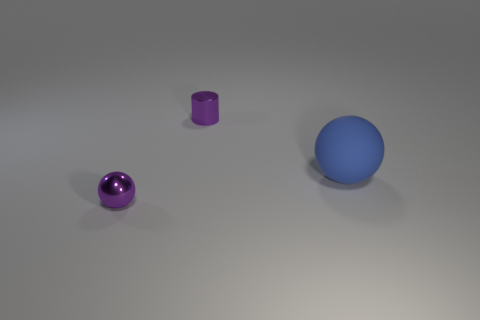Are the purple ball left of the purple cylinder and the ball that is behind the metallic sphere made of the same material?
Your response must be concise. No. There is a shiny thing that is behind the tiny purple thing in front of the small metallic cylinder; what number of small purple objects are left of it?
Offer a terse response. 1. There is a metallic object behind the large blue thing; does it have the same color as the ball that is left of the blue sphere?
Keep it short and to the point. Yes. Is there any other thing that is the same color as the tiny cylinder?
Your response must be concise. Yes. There is a small metallic thing in front of the shiny thing behind the big blue sphere; what is its color?
Give a very brief answer. Purple. Are there any large red things?
Your response must be concise. No. There is a object that is both behind the purple ball and in front of the tiny purple metallic cylinder; what is its color?
Offer a very short reply. Blue. There is a metal thing that is to the right of the metal sphere; is it the same size as the ball behind the tiny metallic ball?
Your answer should be very brief. No. What number of other objects are there of the same size as the metallic cylinder?
Your answer should be compact. 1. There is a metal object that is behind the big matte object; what number of blue things are behind it?
Your response must be concise. 0. 